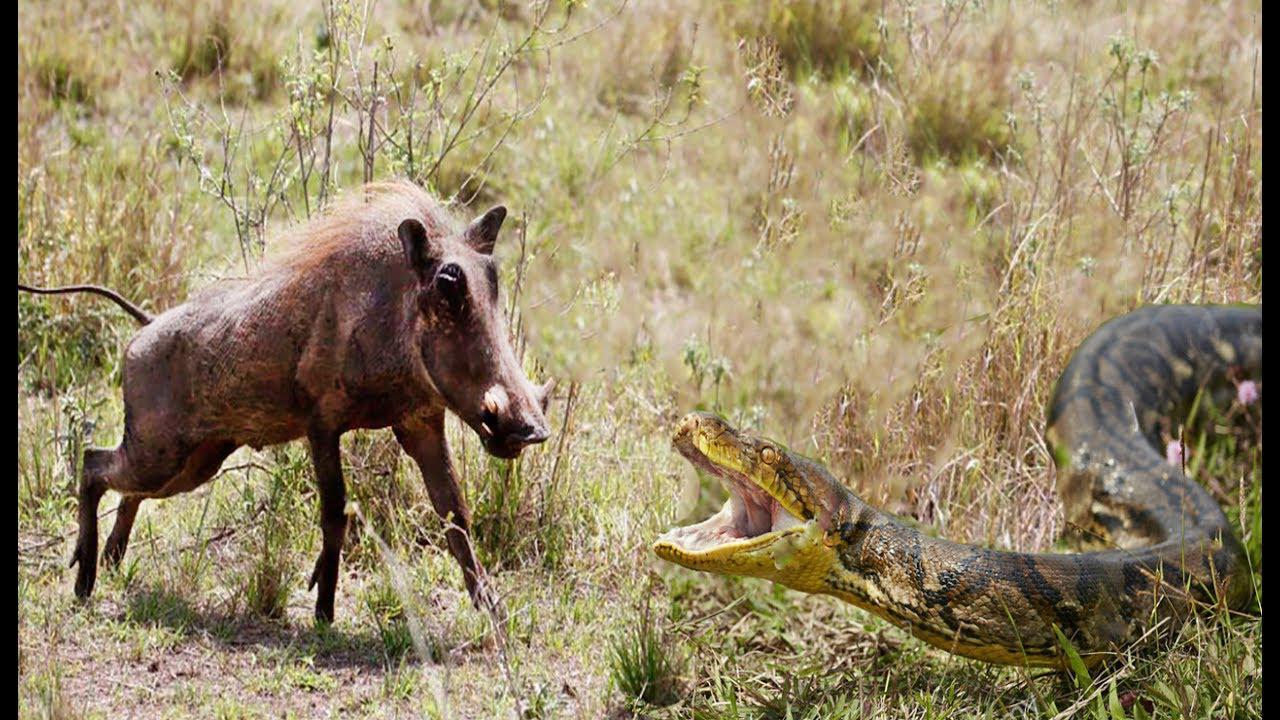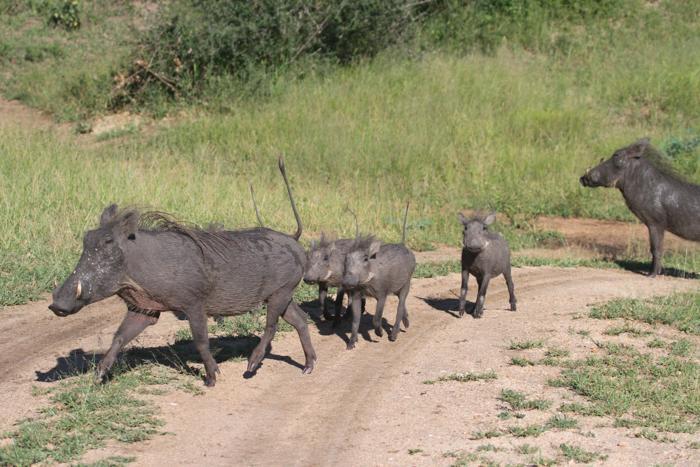The first image is the image on the left, the second image is the image on the right. Analyze the images presented: Is the assertion "There are exactly 5 animals in the image on the right." valid? Answer yes or no. Yes. The first image is the image on the left, the second image is the image on the right. For the images shown, is this caption "There are exactly five animals in the image on the right." true? Answer yes or no. Yes. 